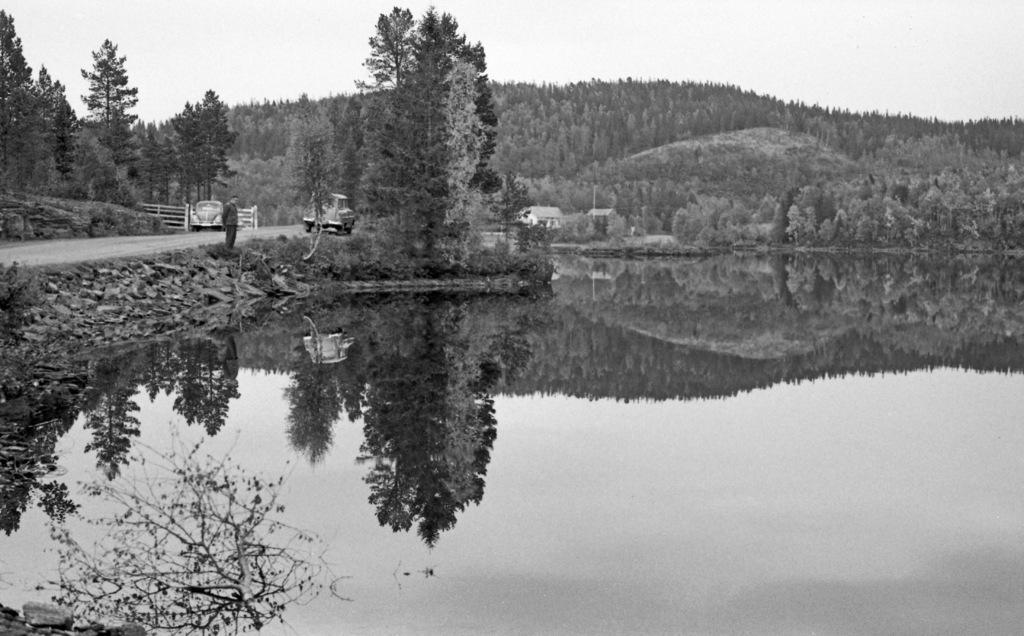What body of water is present in the image? There is a lake in the image. What type of vegetation is visible around the lake? Trees are visible around the lake. What geographical feature can be seen in the background of the image? There is a hill in the image. What part of the natural environment is visible in the image? The sky is visible in the image. Can you describe the person in the image? There is a person standing in front of the lake. What mode of transportation is parked in the image? A vehicle is parked on the road in the image. How many trees are in the recess of the hill in the image? There is no recess in the hill in the image, and therefore no trees can be found there. 